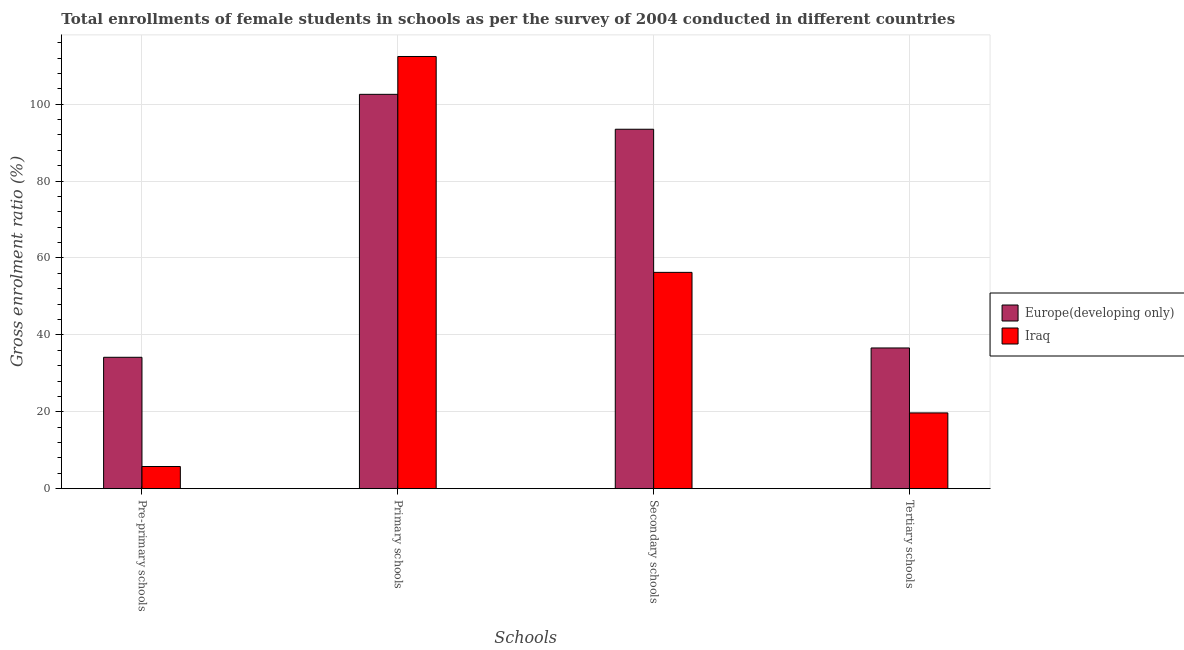How many different coloured bars are there?
Your answer should be compact. 2. How many groups of bars are there?
Ensure brevity in your answer.  4. Are the number of bars on each tick of the X-axis equal?
Give a very brief answer. Yes. How many bars are there on the 1st tick from the left?
Your answer should be compact. 2. What is the label of the 2nd group of bars from the left?
Keep it short and to the point. Primary schools. What is the gross enrolment ratio(female) in primary schools in Europe(developing only)?
Your answer should be compact. 102.57. Across all countries, what is the maximum gross enrolment ratio(female) in primary schools?
Ensure brevity in your answer.  112.41. Across all countries, what is the minimum gross enrolment ratio(female) in tertiary schools?
Ensure brevity in your answer.  19.71. In which country was the gross enrolment ratio(female) in tertiary schools maximum?
Offer a terse response. Europe(developing only). In which country was the gross enrolment ratio(female) in pre-primary schools minimum?
Offer a very short reply. Iraq. What is the total gross enrolment ratio(female) in primary schools in the graph?
Your answer should be compact. 214.98. What is the difference between the gross enrolment ratio(female) in secondary schools in Europe(developing only) and that in Iraq?
Provide a succinct answer. 37.23. What is the difference between the gross enrolment ratio(female) in primary schools in Iraq and the gross enrolment ratio(female) in tertiary schools in Europe(developing only)?
Ensure brevity in your answer.  75.81. What is the average gross enrolment ratio(female) in secondary schools per country?
Your response must be concise. 74.87. What is the difference between the gross enrolment ratio(female) in primary schools and gross enrolment ratio(female) in secondary schools in Europe(developing only)?
Your answer should be very brief. 9.08. What is the ratio of the gross enrolment ratio(female) in pre-primary schools in Europe(developing only) to that in Iraq?
Your response must be concise. 5.93. Is the gross enrolment ratio(female) in pre-primary schools in Europe(developing only) less than that in Iraq?
Provide a succinct answer. No. What is the difference between the highest and the second highest gross enrolment ratio(female) in tertiary schools?
Offer a very short reply. 16.89. What is the difference between the highest and the lowest gross enrolment ratio(female) in secondary schools?
Your response must be concise. 37.23. Is the sum of the gross enrolment ratio(female) in tertiary schools in Europe(developing only) and Iraq greater than the maximum gross enrolment ratio(female) in secondary schools across all countries?
Offer a terse response. No. What does the 1st bar from the left in Secondary schools represents?
Your answer should be compact. Europe(developing only). What does the 1st bar from the right in Primary schools represents?
Make the answer very short. Iraq. Is it the case that in every country, the sum of the gross enrolment ratio(female) in pre-primary schools and gross enrolment ratio(female) in primary schools is greater than the gross enrolment ratio(female) in secondary schools?
Provide a short and direct response. Yes. How many bars are there?
Offer a very short reply. 8. Are all the bars in the graph horizontal?
Your response must be concise. No. What is the difference between two consecutive major ticks on the Y-axis?
Keep it short and to the point. 20. Are the values on the major ticks of Y-axis written in scientific E-notation?
Your response must be concise. No. Does the graph contain any zero values?
Give a very brief answer. No. Does the graph contain grids?
Offer a terse response. Yes. Where does the legend appear in the graph?
Provide a short and direct response. Center right. What is the title of the graph?
Provide a succinct answer. Total enrollments of female students in schools as per the survey of 2004 conducted in different countries. Does "Ukraine" appear as one of the legend labels in the graph?
Provide a succinct answer. No. What is the label or title of the X-axis?
Your response must be concise. Schools. What is the Gross enrolment ratio (%) in Europe(developing only) in Pre-primary schools?
Your answer should be very brief. 34.17. What is the Gross enrolment ratio (%) in Iraq in Pre-primary schools?
Provide a short and direct response. 5.76. What is the Gross enrolment ratio (%) of Europe(developing only) in Primary schools?
Your response must be concise. 102.57. What is the Gross enrolment ratio (%) of Iraq in Primary schools?
Offer a terse response. 112.41. What is the Gross enrolment ratio (%) in Europe(developing only) in Secondary schools?
Provide a succinct answer. 93.49. What is the Gross enrolment ratio (%) of Iraq in Secondary schools?
Provide a succinct answer. 56.26. What is the Gross enrolment ratio (%) in Europe(developing only) in Tertiary schools?
Give a very brief answer. 36.6. What is the Gross enrolment ratio (%) of Iraq in Tertiary schools?
Make the answer very short. 19.71. Across all Schools, what is the maximum Gross enrolment ratio (%) in Europe(developing only)?
Offer a terse response. 102.57. Across all Schools, what is the maximum Gross enrolment ratio (%) in Iraq?
Offer a very short reply. 112.41. Across all Schools, what is the minimum Gross enrolment ratio (%) in Europe(developing only)?
Ensure brevity in your answer.  34.17. Across all Schools, what is the minimum Gross enrolment ratio (%) in Iraq?
Provide a short and direct response. 5.76. What is the total Gross enrolment ratio (%) in Europe(developing only) in the graph?
Keep it short and to the point. 266.83. What is the total Gross enrolment ratio (%) in Iraq in the graph?
Your answer should be compact. 194.14. What is the difference between the Gross enrolment ratio (%) in Europe(developing only) in Pre-primary schools and that in Primary schools?
Offer a terse response. -68.39. What is the difference between the Gross enrolment ratio (%) of Iraq in Pre-primary schools and that in Primary schools?
Your answer should be compact. -106.65. What is the difference between the Gross enrolment ratio (%) of Europe(developing only) in Pre-primary schools and that in Secondary schools?
Make the answer very short. -59.31. What is the difference between the Gross enrolment ratio (%) of Iraq in Pre-primary schools and that in Secondary schools?
Provide a short and direct response. -50.5. What is the difference between the Gross enrolment ratio (%) of Europe(developing only) in Pre-primary schools and that in Tertiary schools?
Make the answer very short. -2.43. What is the difference between the Gross enrolment ratio (%) of Iraq in Pre-primary schools and that in Tertiary schools?
Offer a very short reply. -13.94. What is the difference between the Gross enrolment ratio (%) of Europe(developing only) in Primary schools and that in Secondary schools?
Ensure brevity in your answer.  9.08. What is the difference between the Gross enrolment ratio (%) of Iraq in Primary schools and that in Secondary schools?
Offer a very short reply. 56.15. What is the difference between the Gross enrolment ratio (%) of Europe(developing only) in Primary schools and that in Tertiary schools?
Make the answer very short. 65.97. What is the difference between the Gross enrolment ratio (%) in Iraq in Primary schools and that in Tertiary schools?
Keep it short and to the point. 92.71. What is the difference between the Gross enrolment ratio (%) in Europe(developing only) in Secondary schools and that in Tertiary schools?
Keep it short and to the point. 56.89. What is the difference between the Gross enrolment ratio (%) in Iraq in Secondary schools and that in Tertiary schools?
Provide a short and direct response. 36.55. What is the difference between the Gross enrolment ratio (%) in Europe(developing only) in Pre-primary schools and the Gross enrolment ratio (%) in Iraq in Primary schools?
Provide a succinct answer. -78.24. What is the difference between the Gross enrolment ratio (%) in Europe(developing only) in Pre-primary schools and the Gross enrolment ratio (%) in Iraq in Secondary schools?
Offer a terse response. -22.09. What is the difference between the Gross enrolment ratio (%) of Europe(developing only) in Pre-primary schools and the Gross enrolment ratio (%) of Iraq in Tertiary schools?
Your answer should be compact. 14.47. What is the difference between the Gross enrolment ratio (%) in Europe(developing only) in Primary schools and the Gross enrolment ratio (%) in Iraq in Secondary schools?
Your answer should be compact. 46.31. What is the difference between the Gross enrolment ratio (%) of Europe(developing only) in Primary schools and the Gross enrolment ratio (%) of Iraq in Tertiary schools?
Your answer should be compact. 82.86. What is the difference between the Gross enrolment ratio (%) of Europe(developing only) in Secondary schools and the Gross enrolment ratio (%) of Iraq in Tertiary schools?
Keep it short and to the point. 73.78. What is the average Gross enrolment ratio (%) in Europe(developing only) per Schools?
Your response must be concise. 66.71. What is the average Gross enrolment ratio (%) in Iraq per Schools?
Offer a very short reply. 48.54. What is the difference between the Gross enrolment ratio (%) in Europe(developing only) and Gross enrolment ratio (%) in Iraq in Pre-primary schools?
Offer a very short reply. 28.41. What is the difference between the Gross enrolment ratio (%) in Europe(developing only) and Gross enrolment ratio (%) in Iraq in Primary schools?
Give a very brief answer. -9.85. What is the difference between the Gross enrolment ratio (%) of Europe(developing only) and Gross enrolment ratio (%) of Iraq in Secondary schools?
Give a very brief answer. 37.23. What is the difference between the Gross enrolment ratio (%) in Europe(developing only) and Gross enrolment ratio (%) in Iraq in Tertiary schools?
Offer a very short reply. 16.89. What is the ratio of the Gross enrolment ratio (%) in Europe(developing only) in Pre-primary schools to that in Primary schools?
Offer a terse response. 0.33. What is the ratio of the Gross enrolment ratio (%) in Iraq in Pre-primary schools to that in Primary schools?
Your answer should be very brief. 0.05. What is the ratio of the Gross enrolment ratio (%) of Europe(developing only) in Pre-primary schools to that in Secondary schools?
Your response must be concise. 0.37. What is the ratio of the Gross enrolment ratio (%) in Iraq in Pre-primary schools to that in Secondary schools?
Provide a short and direct response. 0.1. What is the ratio of the Gross enrolment ratio (%) of Europe(developing only) in Pre-primary schools to that in Tertiary schools?
Your response must be concise. 0.93. What is the ratio of the Gross enrolment ratio (%) of Iraq in Pre-primary schools to that in Tertiary schools?
Keep it short and to the point. 0.29. What is the ratio of the Gross enrolment ratio (%) of Europe(developing only) in Primary schools to that in Secondary schools?
Provide a short and direct response. 1.1. What is the ratio of the Gross enrolment ratio (%) of Iraq in Primary schools to that in Secondary schools?
Keep it short and to the point. 2. What is the ratio of the Gross enrolment ratio (%) in Europe(developing only) in Primary schools to that in Tertiary schools?
Your answer should be very brief. 2.8. What is the ratio of the Gross enrolment ratio (%) in Iraq in Primary schools to that in Tertiary schools?
Make the answer very short. 5.7. What is the ratio of the Gross enrolment ratio (%) in Europe(developing only) in Secondary schools to that in Tertiary schools?
Give a very brief answer. 2.55. What is the ratio of the Gross enrolment ratio (%) in Iraq in Secondary schools to that in Tertiary schools?
Provide a short and direct response. 2.85. What is the difference between the highest and the second highest Gross enrolment ratio (%) of Europe(developing only)?
Your response must be concise. 9.08. What is the difference between the highest and the second highest Gross enrolment ratio (%) in Iraq?
Keep it short and to the point. 56.15. What is the difference between the highest and the lowest Gross enrolment ratio (%) in Europe(developing only)?
Offer a terse response. 68.39. What is the difference between the highest and the lowest Gross enrolment ratio (%) of Iraq?
Offer a terse response. 106.65. 